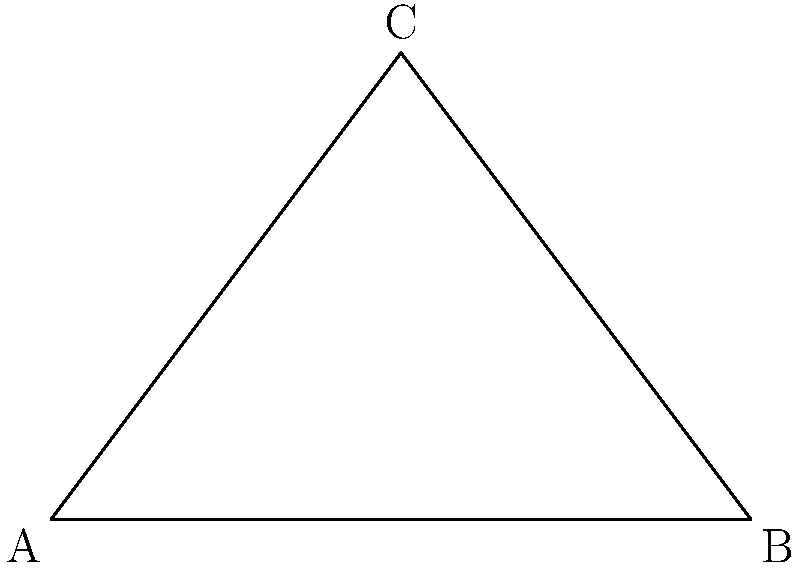In a hemp processing facility, two conveyor belts meet at point A. One belt runs from A to B, and the other from A to C. Given that AB = 6 meters, BC = 5 meters, and AC = 5 meters, calculate the angle $\theta$ between the two conveyor belts at point A. To solve this problem, we'll use the law of cosines. Here's a step-by-step approach:

1) The law of cosines states: 
   $c^2 = a^2 + b^2 - 2ab \cos(C)$
   where $C$ is the angle opposite the side $c$.

2) In our case, we want to find angle $\theta$ at point A. We know:
   AB = c = 6 meters
   AC = b = 5 meters
   BC = a = 5 meters

3) Substituting these values into the law of cosines:
   $5^2 = 6^2 + 5^2 - 2(6)(5) \cos(\theta)$

4) Simplify:
   $25 = 36 + 25 - 60 \cos(\theta)$

5) Subtract 61 from both sides:
   $-36 = -60 \cos(\theta)$

6) Divide both sides by -60:
   $\frac{3}{5} = \cos(\theta)$

7) Take the inverse cosine (arccos) of both sides:
   $\theta = \arccos(\frac{3}{5})$

8) Calculate the result:
   $\theta \approx 53.13°$

Therefore, the angle between the two conveyor belts is approximately 53.13°.
Answer: $53.13°$ 